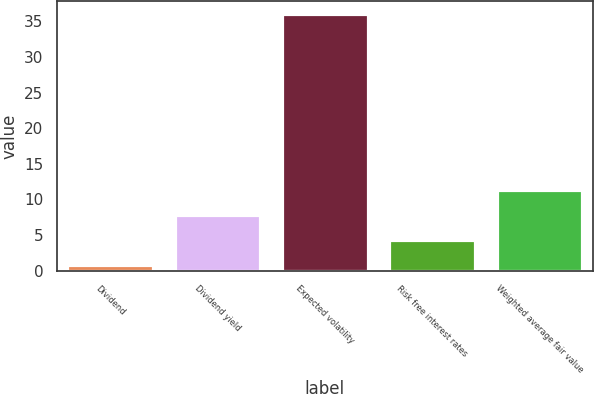Convert chart. <chart><loc_0><loc_0><loc_500><loc_500><bar_chart><fcel>Dividend<fcel>Dividend yield<fcel>Expected volatility<fcel>Risk free interest rates<fcel>Weighted average fair value<nl><fcel>0.75<fcel>7.81<fcel>36<fcel>4.28<fcel>11.34<nl></chart> 